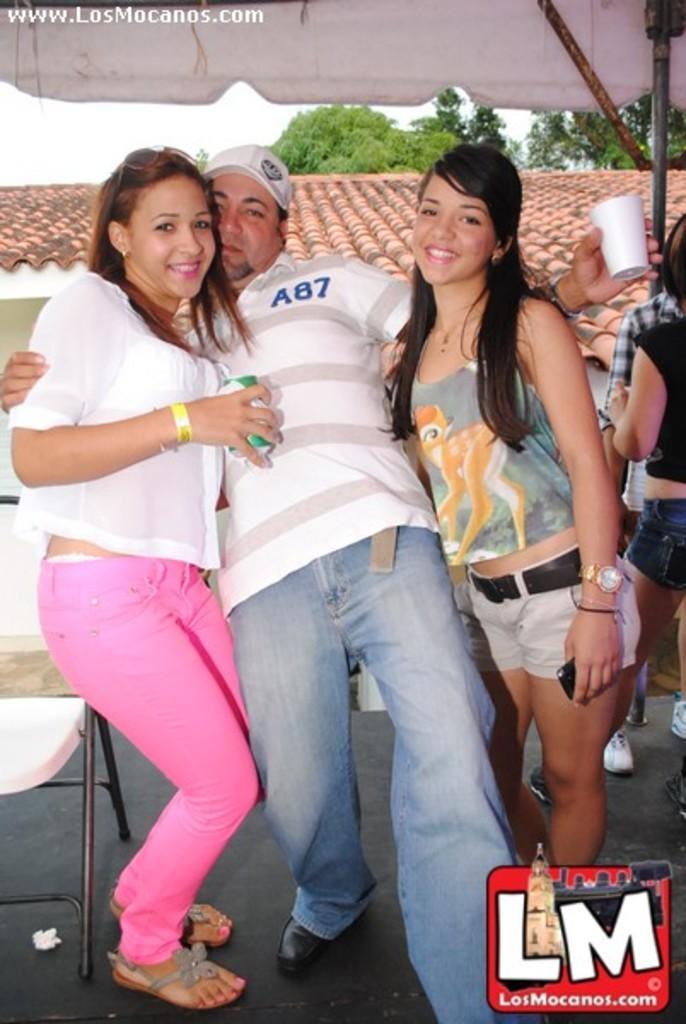In one or two sentences, can you explain what this image depicts? In this image we can see some people standing. In that some are holding a tin, glass and a device. On the backside we can see a chair, a house with a roof, a tent with a metal pole, some trees and the sky. 